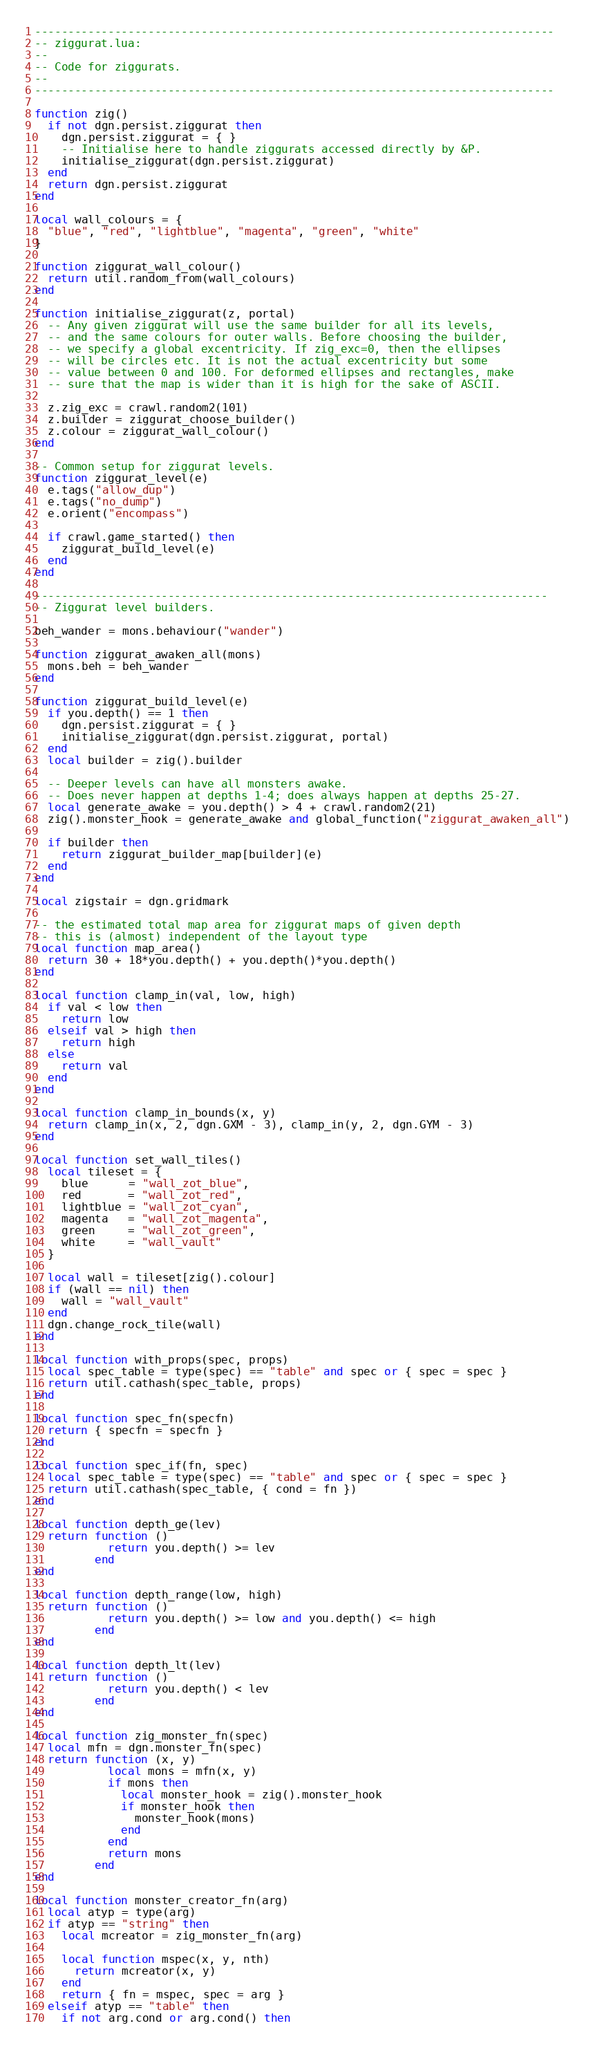<code> <loc_0><loc_0><loc_500><loc_500><_Lua_>------------------------------------------------------------------------------
-- ziggurat.lua:
--
-- Code for ziggurats.
--
------------------------------------------------------------------------------

function zig()
  if not dgn.persist.ziggurat then
    dgn.persist.ziggurat = { }
    -- Initialise here to handle ziggurats accessed directly by &P.
    initialise_ziggurat(dgn.persist.ziggurat)
  end
  return dgn.persist.ziggurat
end

local wall_colours = {
  "blue", "red", "lightblue", "magenta", "green", "white"
}

function ziggurat_wall_colour()
  return util.random_from(wall_colours)
end

function initialise_ziggurat(z, portal)
  -- Any given ziggurat will use the same builder for all its levels,
  -- and the same colours for outer walls. Before choosing the builder,
  -- we specify a global excentricity. If zig_exc=0, then the ellipses
  -- will be circles etc. It is not the actual excentricity but some
  -- value between 0 and 100. For deformed ellipses and rectangles, make
  -- sure that the map is wider than it is high for the sake of ASCII.

  z.zig_exc = crawl.random2(101)
  z.builder = ziggurat_choose_builder()
  z.colour = ziggurat_wall_colour()
end

-- Common setup for ziggurat levels.
function ziggurat_level(e)
  e.tags("allow_dup")
  e.tags("no_dump")
  e.orient("encompass")

  if crawl.game_started() then
    ziggurat_build_level(e)
  end
end

-----------------------------------------------------------------------------
-- Ziggurat level builders.

beh_wander = mons.behaviour("wander")

function ziggurat_awaken_all(mons)
  mons.beh = beh_wander
end

function ziggurat_build_level(e)
  if you.depth() == 1 then
    dgn.persist.ziggurat = { }
    initialise_ziggurat(dgn.persist.ziggurat, portal)
  end
  local builder = zig().builder

  -- Deeper levels can have all monsters awake.
  -- Does never happen at depths 1-4; does always happen at depths 25-27.
  local generate_awake = you.depth() > 4 + crawl.random2(21)
  zig().monster_hook = generate_awake and global_function("ziggurat_awaken_all")

  if builder then
    return ziggurat_builder_map[builder](e)
  end
end

local zigstair = dgn.gridmark

-- the estimated total map area for ziggurat maps of given depth
-- this is (almost) independent of the layout type
local function map_area()
  return 30 + 18*you.depth() + you.depth()*you.depth()
end

local function clamp_in(val, low, high)
  if val < low then
    return low
  elseif val > high then
    return high
  else
    return val
  end
end

local function clamp_in_bounds(x, y)
  return clamp_in(x, 2, dgn.GXM - 3), clamp_in(y, 2, dgn.GYM - 3)
end

local function set_wall_tiles()
  local tileset = {
    blue      = "wall_zot_blue",
    red       = "wall_zot_red",
    lightblue = "wall_zot_cyan",
    magenta   = "wall_zot_magenta",
    green     = "wall_zot_green",
    white     = "wall_vault"
  }

  local wall = tileset[zig().colour]
  if (wall == nil) then
    wall = "wall_vault"
  end
  dgn.change_rock_tile(wall)
end

local function with_props(spec, props)
  local spec_table = type(spec) == "table" and spec or { spec = spec }
  return util.cathash(spec_table, props)
end

local function spec_fn(specfn)
  return { specfn = specfn }
end

local function spec_if(fn, spec)
  local spec_table = type(spec) == "table" and spec or { spec = spec }
  return util.cathash(spec_table, { cond = fn })
end

local function depth_ge(lev)
  return function ()
           return you.depth() >= lev
         end
end

local function depth_range(low, high)
  return function ()
           return you.depth() >= low and you.depth() <= high
         end
end

local function depth_lt(lev)
  return function ()
           return you.depth() < lev
         end
end

local function zig_monster_fn(spec)
  local mfn = dgn.monster_fn(spec)
  return function (x, y)
           local mons = mfn(x, y)
           if mons then
             local monster_hook = zig().monster_hook
             if monster_hook then
               monster_hook(mons)
             end
           end
           return mons
         end
end

local function monster_creator_fn(arg)
  local atyp = type(arg)
  if atyp == "string" then
    local mcreator = zig_monster_fn(arg)

    local function mspec(x, y, nth)
      return mcreator(x, y)
    end
    return { fn = mspec, spec = arg }
  elseif atyp == "table" then
    if not arg.cond or arg.cond() then</code> 